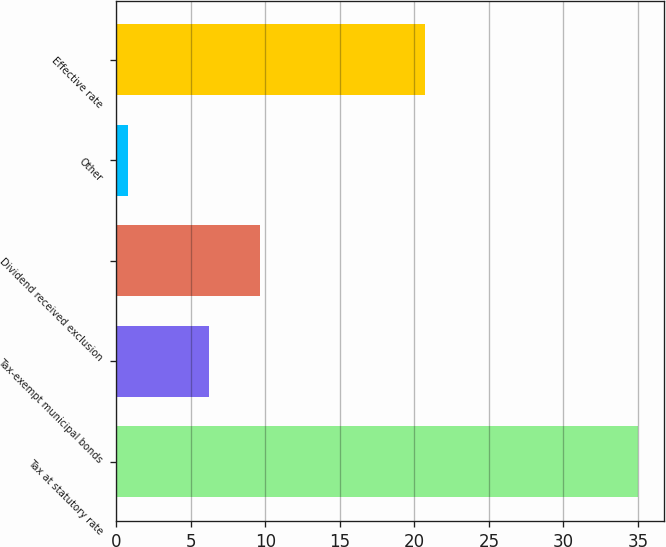Convert chart. <chart><loc_0><loc_0><loc_500><loc_500><bar_chart><fcel>Tax at statutory rate<fcel>Tax-exempt municipal bonds<fcel>Dividend received exclusion<fcel>Other<fcel>Effective rate<nl><fcel>35<fcel>6.2<fcel>9.62<fcel>0.8<fcel>20.7<nl></chart> 